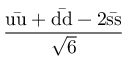<formula> <loc_0><loc_0><loc_500><loc_500>\frac { u { \bar { u } } + d { \bar { d } } - 2 s { \bar { s } } } { \sqrt { 6 } }</formula> 